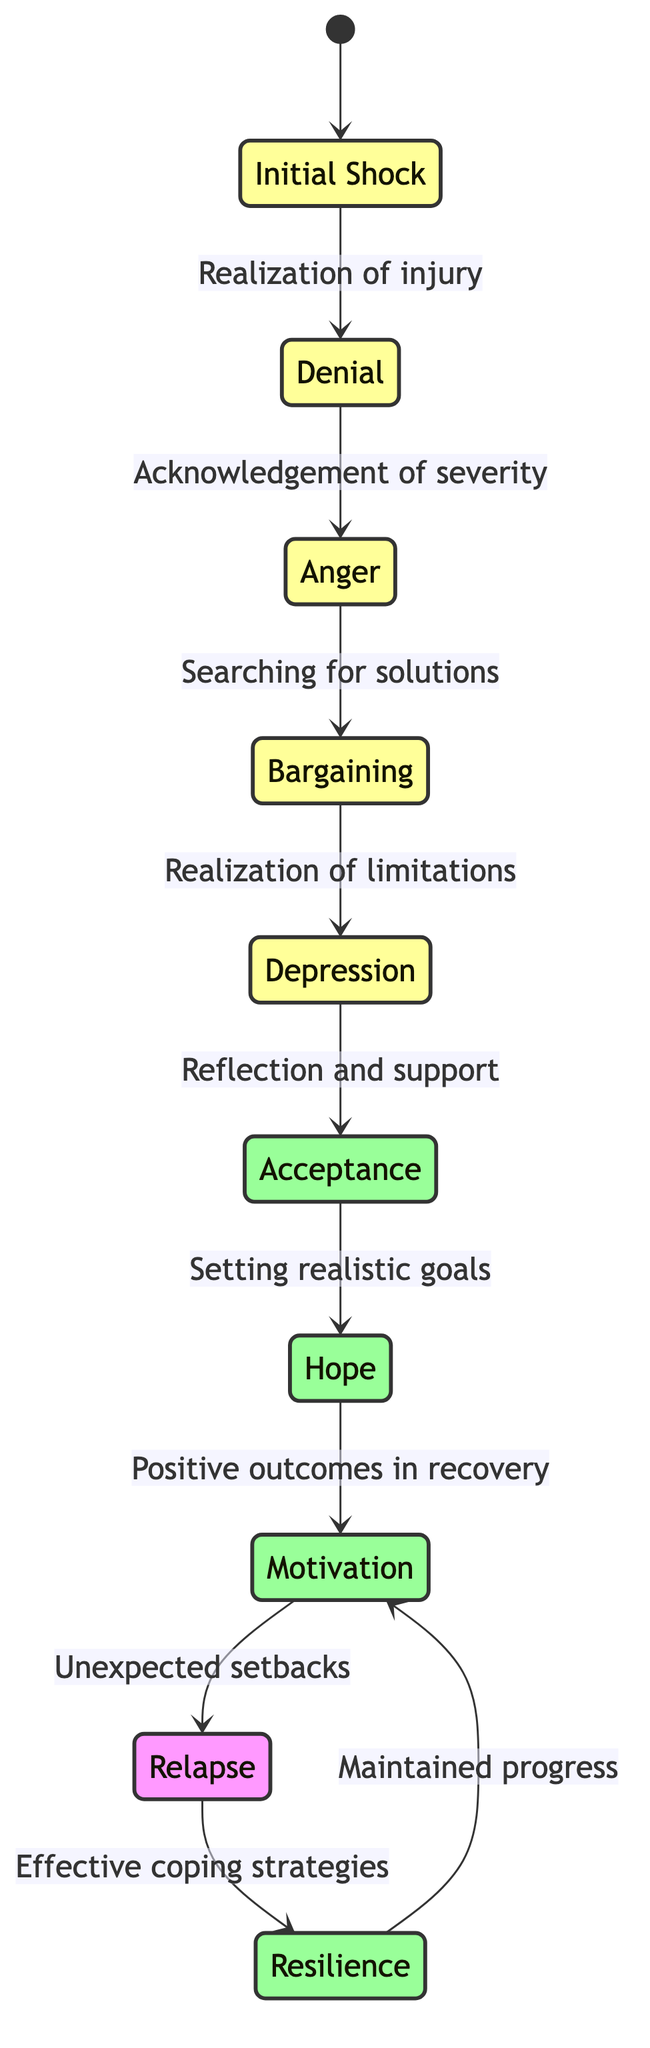What's the first emotional state in the diagram? The diagram starts with the node labeled "Initial Shock," which is the first emotional state.
Answer: Initial Shock How many total emotional states are represented in the diagram? Counting each unique state from the list, there are ten emotional states shown in the diagram.
Answer: 10 What triggers the transition from Acceptance to Hope? The transition from the emotional state "Acceptance" to "Hope" is triggered by "Setting realistic goals," as indicated by the arrow between these two states.
Answer: Setting realistic goals Identify the transition that leads from Denial to Anger. The transition that connects "Denial" to "Anger" is triggered by "Acknowledgement of severity," which is the direct relationship indicated in the diagram.
Answer: Acknowledgement of severity What is the last emotional state one can reach after the state of Motivation if setbacks occur? Following the state "Motivation," if unexpected setbacks happen, the athlete would transition to the state of "Relapse," as per the flow of the diagram.
Answer: Relapse How many transitions lead to the state of Resilience? Two transitions lead to the state of "Resilience": one from "Relapse" with effective coping strategies and one from "Motivation" with maintained progress. Therefore, the total is two transitions.
Answer: 2 What describes the emotional state directly before Depression? The emotional state directly before "Depression" is "Bargaining," as shown in the transition leading into "Depression."
Answer: Bargaining Which emotional states are classified as positive? The states designated as positive in the diagram are "Acceptance," "Hope," "Motivation," and "Resilience."
Answer: Acceptance, Hope, Motivation, Resilience What happens if an athlete experiences a relapse? If an athlete experiences a relapse, they transition to the emotional state "Resilience," triggered by effective coping strategies, as indicated in the diagram.
Answer: Resilience 